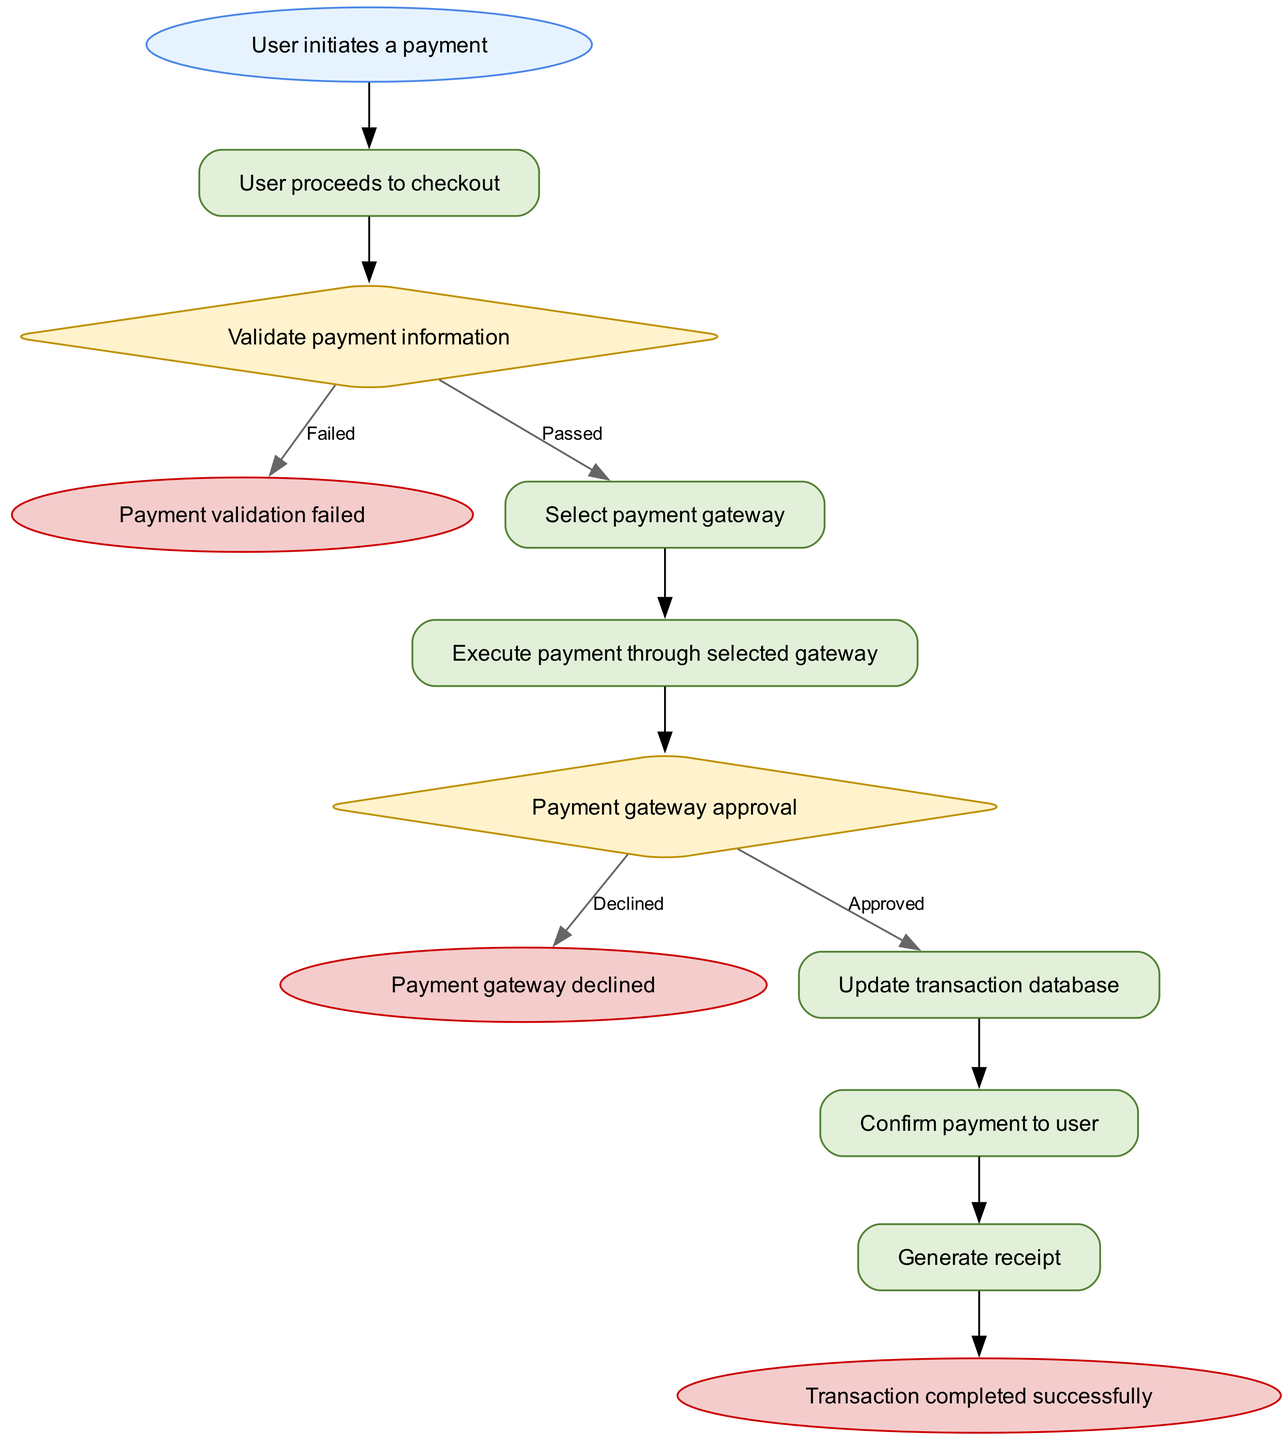What is the initial step in the transaction flow? The initial step in the transaction flow is where the user initiates a payment. This is depicted in the diagram as the first node labeled "User initiates a payment."
Answer: User initiates a payment How many decision nodes are present in the diagram? The diagram contains two decision nodes: one for validating payment information and another for payment gateway approval. These are critical points in the transaction flow where the process can diverge based on the outcome.
Answer: 2 What happens if payment validation fails? If payment validation fails, the next step in the flow is to prompt the user to re-enter payment details. This action leads to a termination of the transaction process if the validation is unsuccessful.
Answer: Prompt user to re-enter payment details After selecting a payment gateway, what is the next action? After the user selects a payment gateway, the next action is to execute the payment through the selected gateway. This represents the movement from choosing an option to taking action based on that choice.
Answer: Execute payment through selected gateway What is the outcome if the payment gateway approval is declined? If the payment gateway approval is declined, the process concludes with notifying the user and terminating the transaction. This response highlights the consequence of a failed approval in the transaction flow.
Answer: Notify user and terminate the transaction What steps follow after the payment is approved? Once the payment is approved, the subsequent steps are to update the transaction database, confirm the payment to the user, and generate a receipt. These steps ensure that the transaction is documented and the user is informed of its completion.
Answer: Update transaction database, confirm payment, generate receipt What shape is associated with the start of the flow? The shape associated with the start of the flow is an oval, which is a common symbol used to indicate the beginning of a process in a flowchart. This shape is distinct and easily identifiable.
Answer: Oval What action is taken right before generating a receipt? Before generating a receipt, the action taken is to confirm payment to the user, which is crucial for keeping the user informed about their transaction and its status.
Answer: Confirm payment to user 